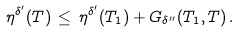Convert formula to latex. <formula><loc_0><loc_0><loc_500><loc_500>\eta ^ { \delta ^ { \prime } } ( T ) \, \leq \, \eta ^ { \delta ^ { \prime } } ( T _ { 1 } ) + G _ { \delta ^ { \prime \prime } } ( T _ { 1 } , T ) \, .</formula> 